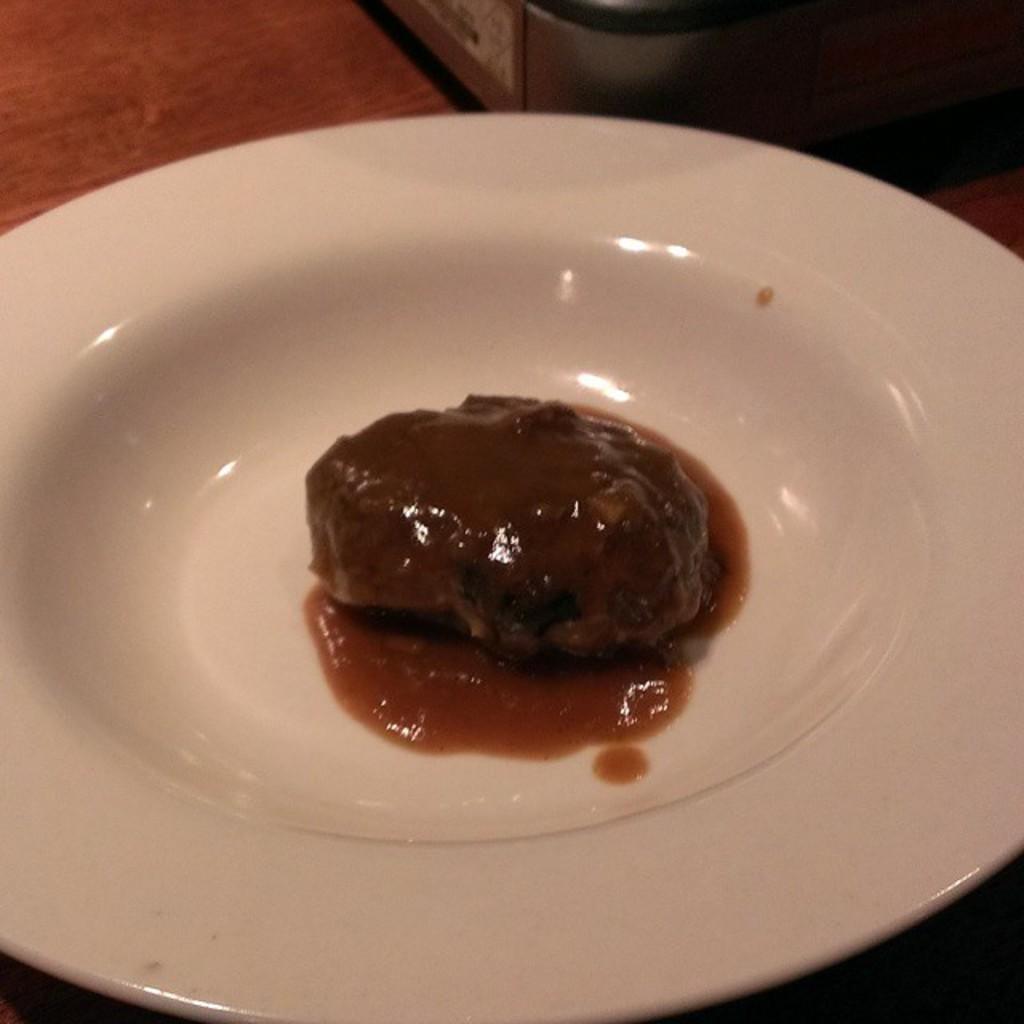Describe this image in one or two sentences. In this image there is a plate on the table. On the plate there is some food. Top of the image there is an object on the table. 